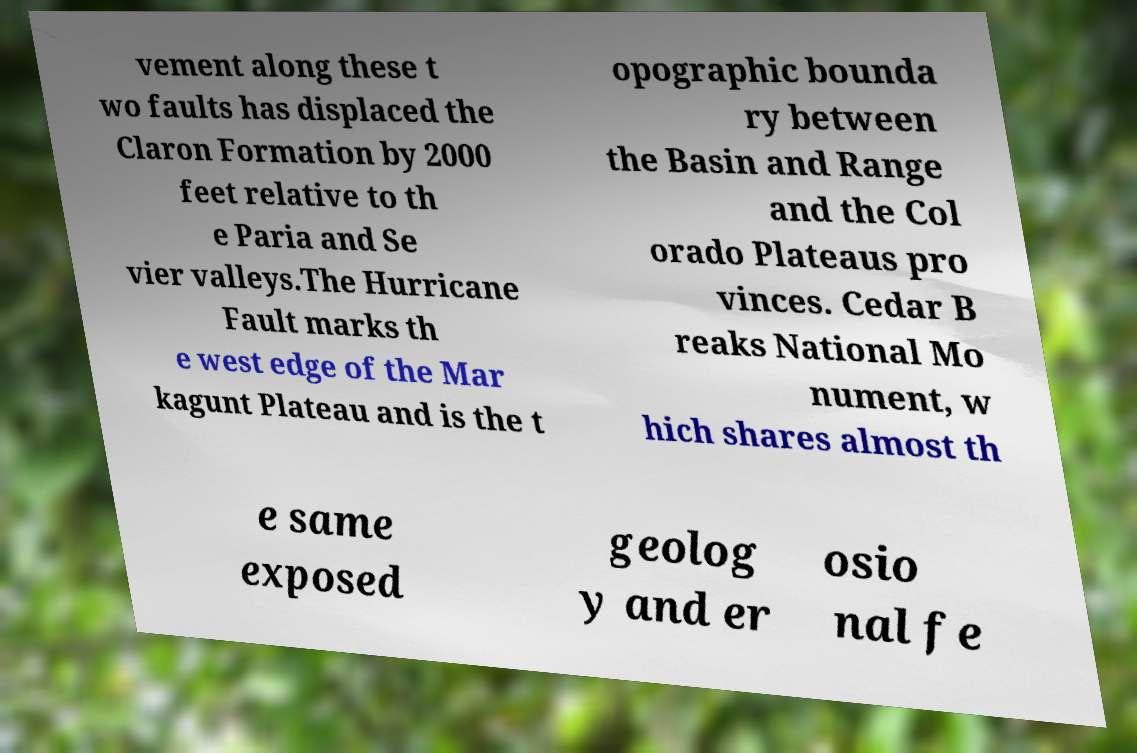Can you accurately transcribe the text from the provided image for me? vement along these t wo faults has displaced the Claron Formation by 2000 feet relative to th e Paria and Se vier valleys.The Hurricane Fault marks th e west edge of the Mar kagunt Plateau and is the t opographic bounda ry between the Basin and Range and the Col orado Plateaus pro vinces. Cedar B reaks National Mo nument, w hich shares almost th e same exposed geolog y and er osio nal fe 